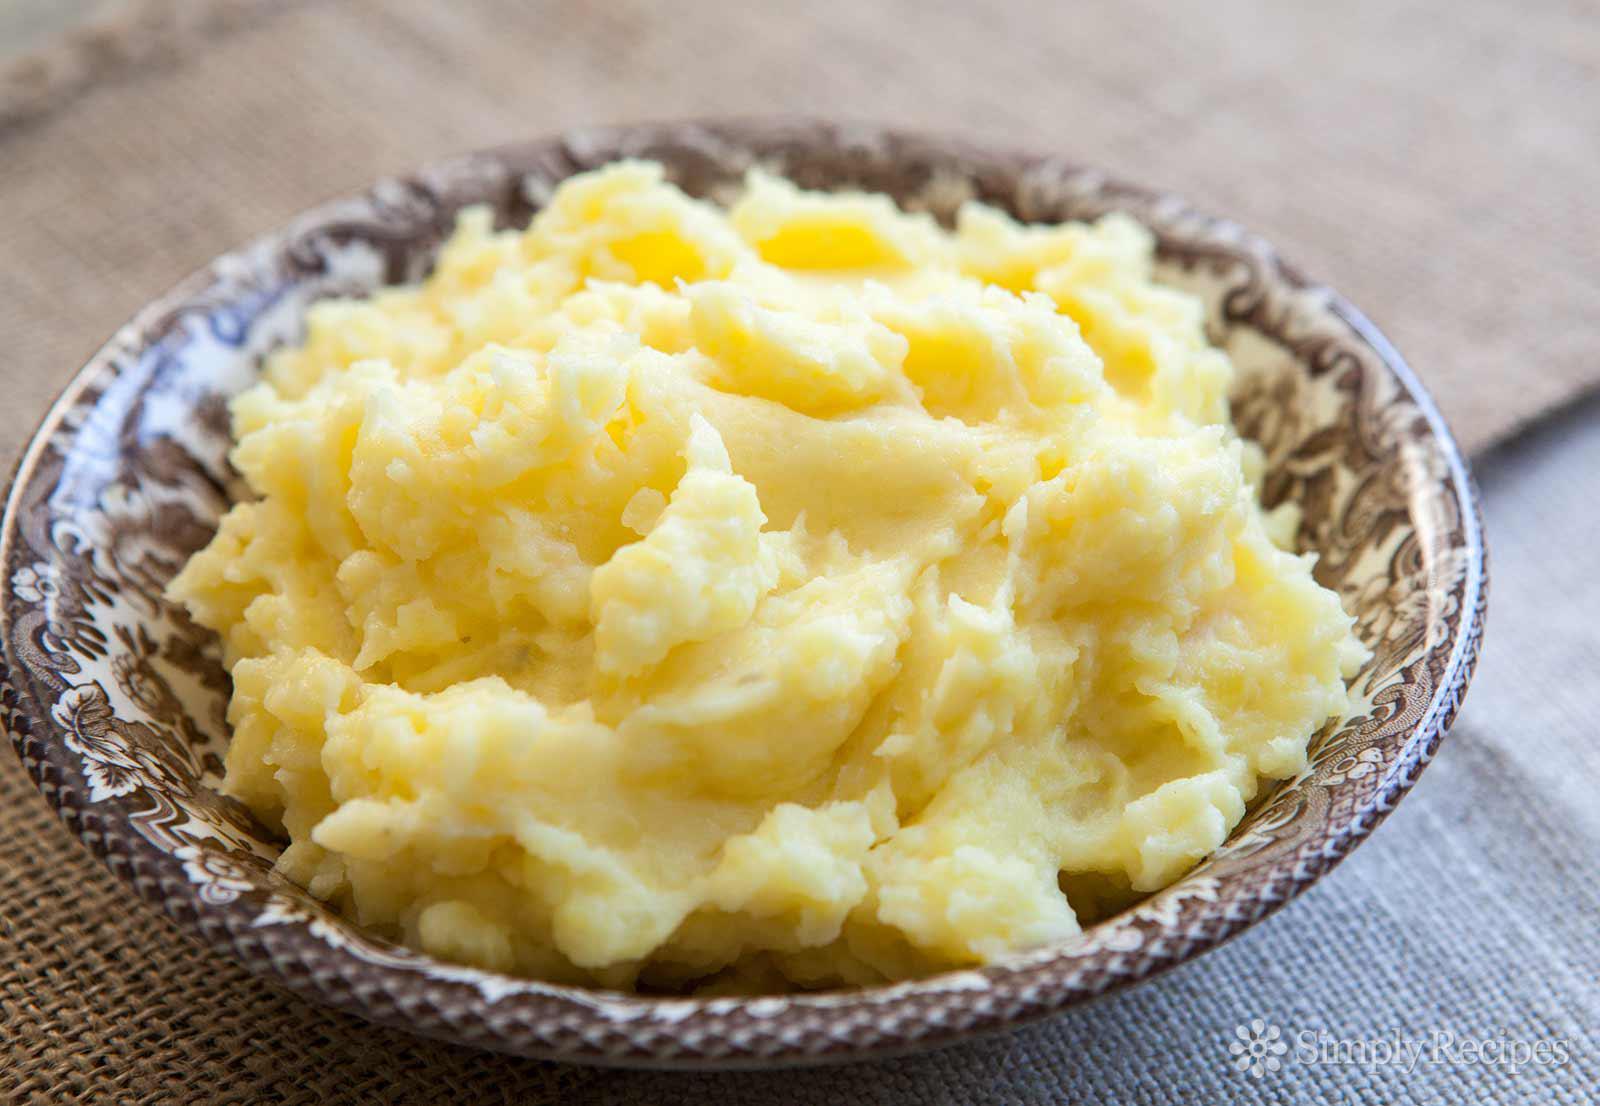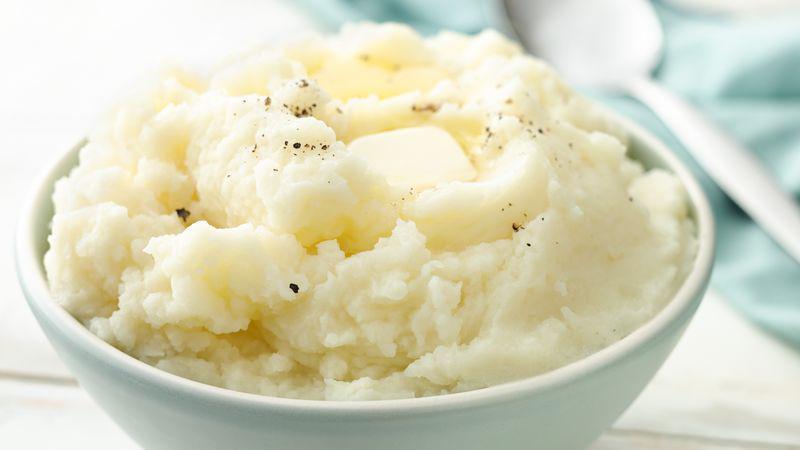The first image is the image on the left, the second image is the image on the right. Evaluate the accuracy of this statement regarding the images: "the mashed potato on the right image is on a white bowl.". Is it true? Answer yes or no. Yes. 